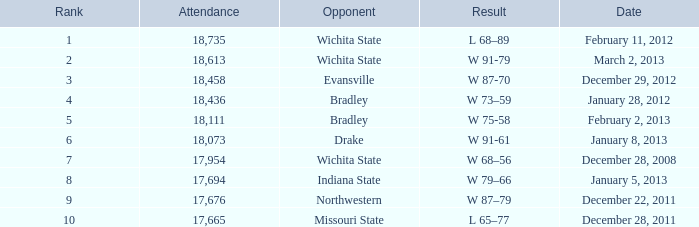What is the position for february 11, 2012 when the attendance is below 18,735? None. 